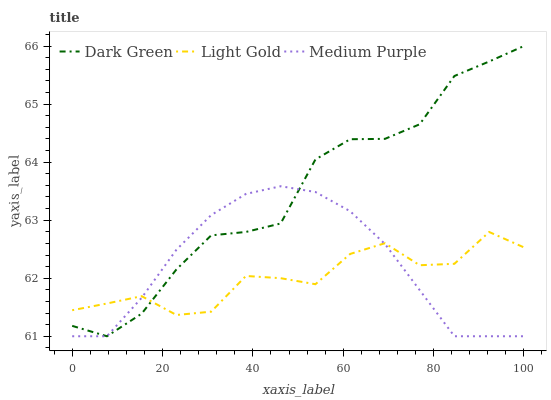Does Light Gold have the minimum area under the curve?
Answer yes or no. Yes. Does Dark Green have the maximum area under the curve?
Answer yes or no. Yes. Does Dark Green have the minimum area under the curve?
Answer yes or no. No. Does Light Gold have the maximum area under the curve?
Answer yes or no. No. Is Medium Purple the smoothest?
Answer yes or no. Yes. Is Light Gold the roughest?
Answer yes or no. Yes. Is Dark Green the smoothest?
Answer yes or no. No. Is Dark Green the roughest?
Answer yes or no. No. Does Medium Purple have the lowest value?
Answer yes or no. Yes. Does Light Gold have the lowest value?
Answer yes or no. No. Does Dark Green have the highest value?
Answer yes or no. Yes. Does Light Gold have the highest value?
Answer yes or no. No. Does Dark Green intersect Medium Purple?
Answer yes or no. Yes. Is Dark Green less than Medium Purple?
Answer yes or no. No. Is Dark Green greater than Medium Purple?
Answer yes or no. No. 